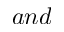Convert formula to latex. <formula><loc_0><loc_0><loc_500><loc_500>a n d</formula> 